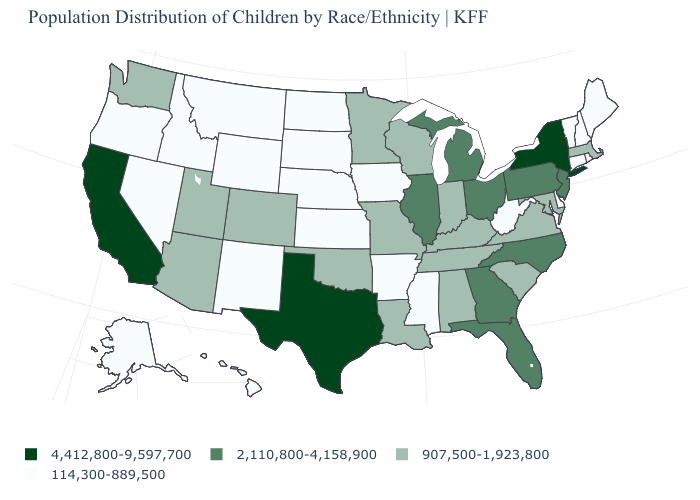Which states have the lowest value in the USA?
Short answer required. Alaska, Arkansas, Connecticut, Delaware, Hawaii, Idaho, Iowa, Kansas, Maine, Mississippi, Montana, Nebraska, Nevada, New Hampshire, New Mexico, North Dakota, Oregon, Rhode Island, South Dakota, Vermont, West Virginia, Wyoming. What is the value of Maryland?
Answer briefly. 907,500-1,923,800. Does New York have the same value as Alabama?
Write a very short answer. No. How many symbols are there in the legend?
Concise answer only. 4. Name the states that have a value in the range 2,110,800-4,158,900?
Short answer required. Florida, Georgia, Illinois, Michigan, New Jersey, North Carolina, Ohio, Pennsylvania. Name the states that have a value in the range 4,412,800-9,597,700?
Quick response, please. California, New York, Texas. Among the states that border Nebraska , does Iowa have the lowest value?
Keep it brief. Yes. What is the value of Alaska?
Keep it brief. 114,300-889,500. What is the value of Connecticut?
Give a very brief answer. 114,300-889,500. What is the value of Minnesota?
Write a very short answer. 907,500-1,923,800. Among the states that border Missouri , does Nebraska have the highest value?
Concise answer only. No. What is the value of West Virginia?
Keep it brief. 114,300-889,500. Among the states that border Mississippi , does Tennessee have the highest value?
Write a very short answer. Yes. Name the states that have a value in the range 4,412,800-9,597,700?
Give a very brief answer. California, New York, Texas. What is the highest value in the MidWest ?
Keep it brief. 2,110,800-4,158,900. 